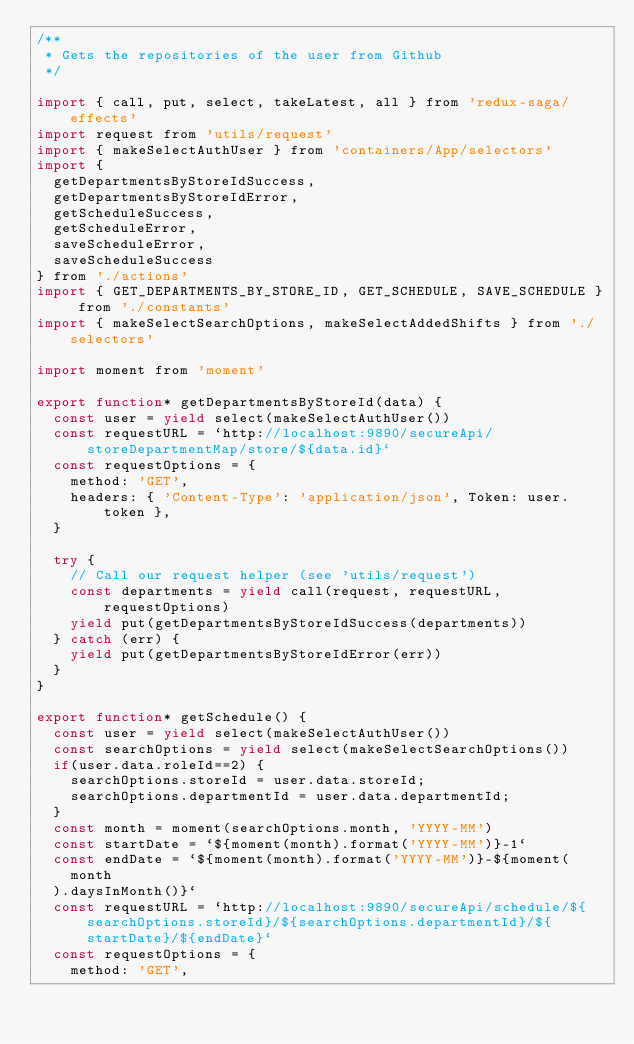Convert code to text. <code><loc_0><loc_0><loc_500><loc_500><_JavaScript_>/**
 * Gets the repositories of the user from Github
 */

import { call, put, select, takeLatest, all } from 'redux-saga/effects'
import request from 'utils/request'
import { makeSelectAuthUser } from 'containers/App/selectors'
import {
  getDepartmentsByStoreIdSuccess,
  getDepartmentsByStoreIdError,
  getScheduleSuccess,
  getScheduleError,
  saveScheduleError,
  saveScheduleSuccess
} from './actions'
import { GET_DEPARTMENTS_BY_STORE_ID, GET_SCHEDULE, SAVE_SCHEDULE } from './constants'
import { makeSelectSearchOptions, makeSelectAddedShifts } from './selectors'

import moment from 'moment'

export function* getDepartmentsByStoreId(data) {
  const user = yield select(makeSelectAuthUser())
  const requestURL = `http://localhost:9890/secureApi/storeDepartmentMap/store/${data.id}`
  const requestOptions = {
    method: 'GET',
    headers: { 'Content-Type': 'application/json', Token: user.token },
  }

  try {
    // Call our request helper (see 'utils/request')
    const departments = yield call(request, requestURL, requestOptions)
    yield put(getDepartmentsByStoreIdSuccess(departments))
  } catch (err) {
    yield put(getDepartmentsByStoreIdError(err))
  }
}

export function* getSchedule() {
  const user = yield select(makeSelectAuthUser())
  const searchOptions = yield select(makeSelectSearchOptions())
  if(user.data.roleId==2) {
    searchOptions.storeId = user.data.storeId;
    searchOptions.departmentId = user.data.departmentId;
  }
  const month = moment(searchOptions.month, 'YYYY-MM')
  const startDate = `${moment(month).format('YYYY-MM')}-1`
  const endDate = `${moment(month).format('YYYY-MM')}-${moment(
    month
  ).daysInMonth()}`
  const requestURL = `http://localhost:9890/secureApi/schedule/${searchOptions.storeId}/${searchOptions.departmentId}/${startDate}/${endDate}`
  const requestOptions = {
    method: 'GET',</code> 